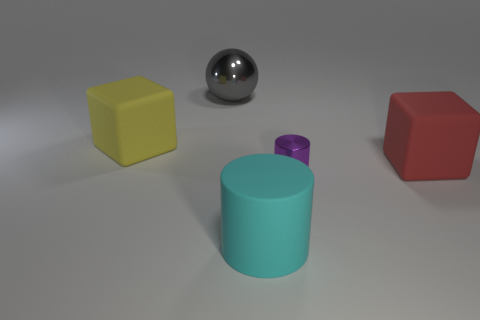There is a big cube that is on the left side of the small metallic thing; is there a red object that is behind it?
Give a very brief answer. No. There is a big yellow thing that is the same shape as the large red thing; what material is it?
Your answer should be compact. Rubber. There is a big object that is right of the tiny metal cylinder; how many large shiny things are in front of it?
Ensure brevity in your answer.  0. Is there anything else that is the same color as the ball?
Your answer should be very brief. No. What number of objects are either large red matte blocks or matte objects to the right of the small purple cylinder?
Ensure brevity in your answer.  1. What material is the object on the right side of the small metallic object that is to the left of the red thing that is in front of the big metallic sphere?
Your response must be concise. Rubber. The ball that is made of the same material as the tiny thing is what size?
Offer a very short reply. Large. What is the color of the matte cube left of the big cube that is in front of the yellow block?
Make the answer very short. Yellow. What number of blue balls are the same material as the cyan object?
Provide a succinct answer. 0. What number of matte objects are big cyan spheres or balls?
Provide a succinct answer. 0. 